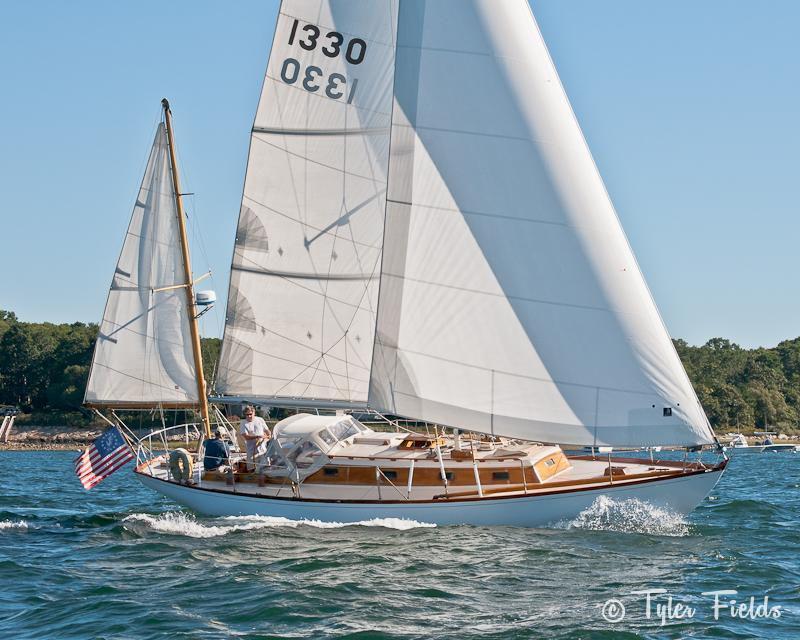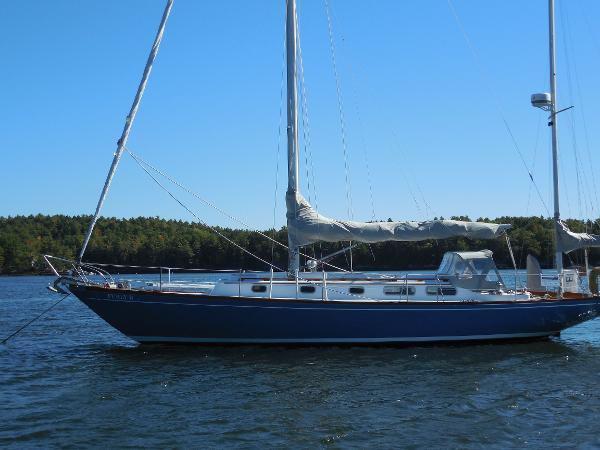The first image is the image on the left, the second image is the image on the right. Examine the images to the left and right. Is the description "At least one of the images has a sky with nimbus clouds." accurate? Answer yes or no. No. 